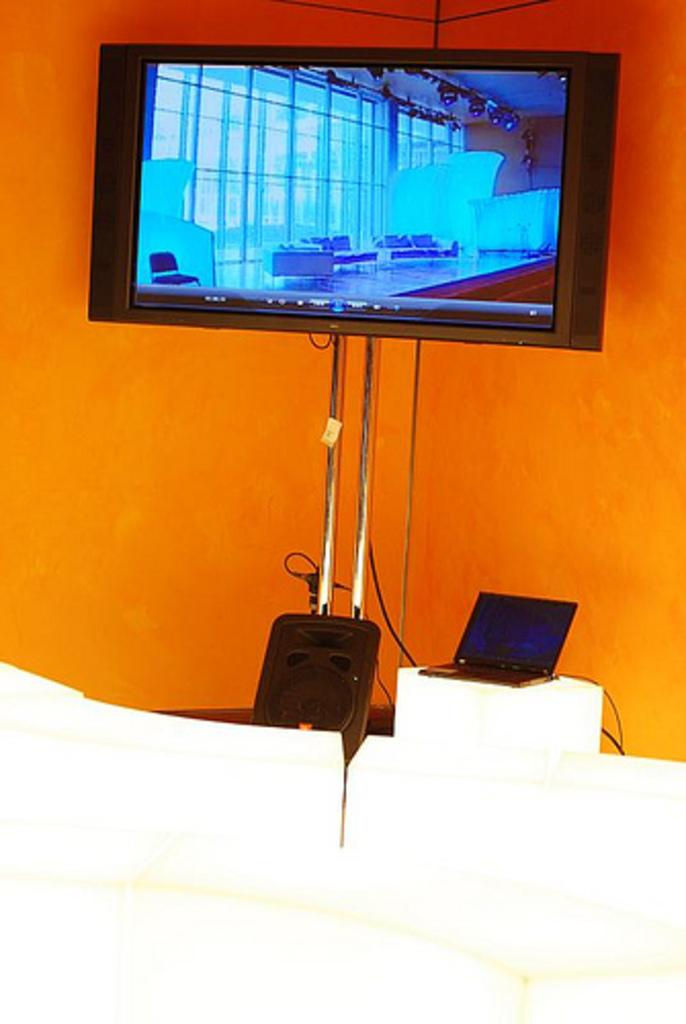What electronic device is the main subject of the image? There is a television in the image. What feature of the television is mentioned in the facts? The television has speakers. What other object can be seen in the image? There is a stand in the image. What additional electronic device is present in the image? There is a laptop in the image. What color is the wall in the image? The wall in the image is orange. What type of mark can be seen on the church in the image? There is no church present in the image, so no marks can be seen on it. How much salt is visible on the laptop in the image? There is no salt present on the laptop in the image. 